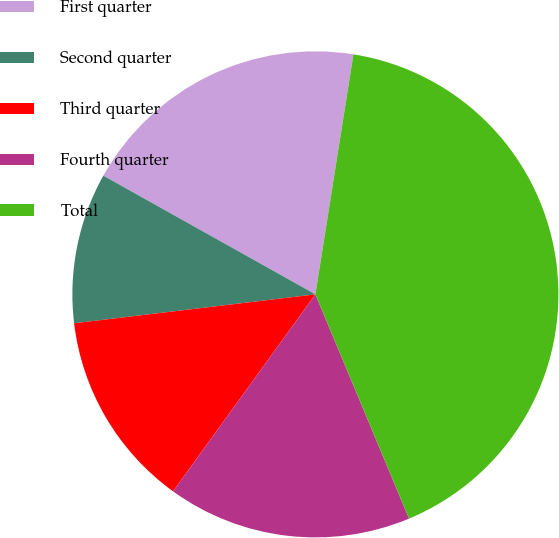Convert chart. <chart><loc_0><loc_0><loc_500><loc_500><pie_chart><fcel>First quarter<fcel>Second quarter<fcel>Third quarter<fcel>Fourth quarter<fcel>Total<nl><fcel>19.38%<fcel>10.02%<fcel>13.14%<fcel>16.26%<fcel>41.2%<nl></chart> 